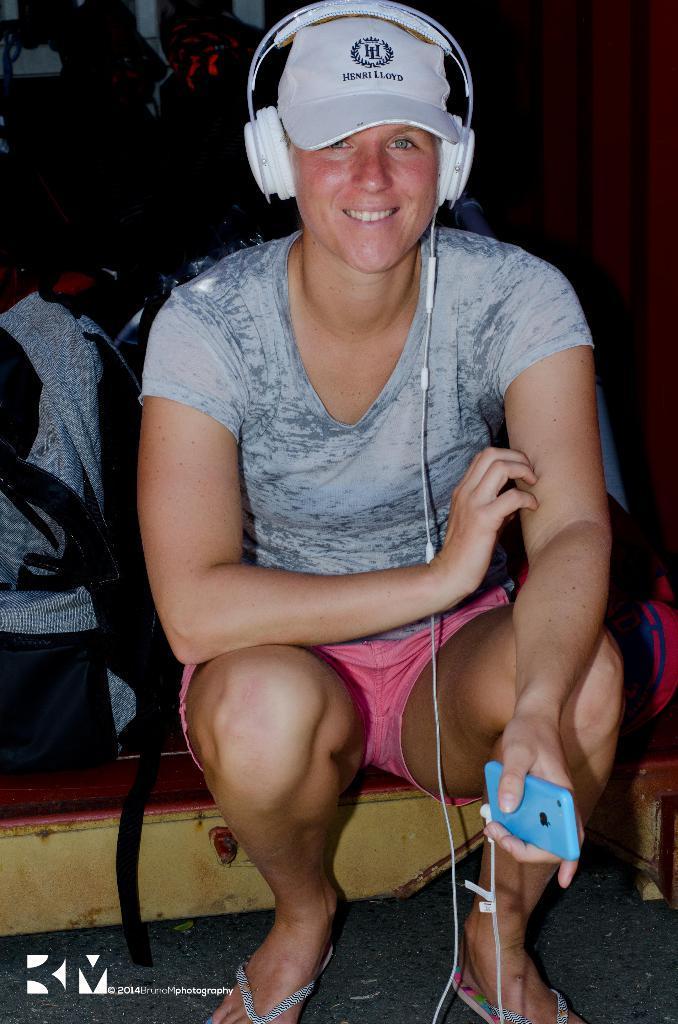Describe this image in one or two sentences. In this picture we can see a woman sitting on the floor. She is holding a mobile with her hand. And she has headsets. And she wear a cap. And she is smiling. 